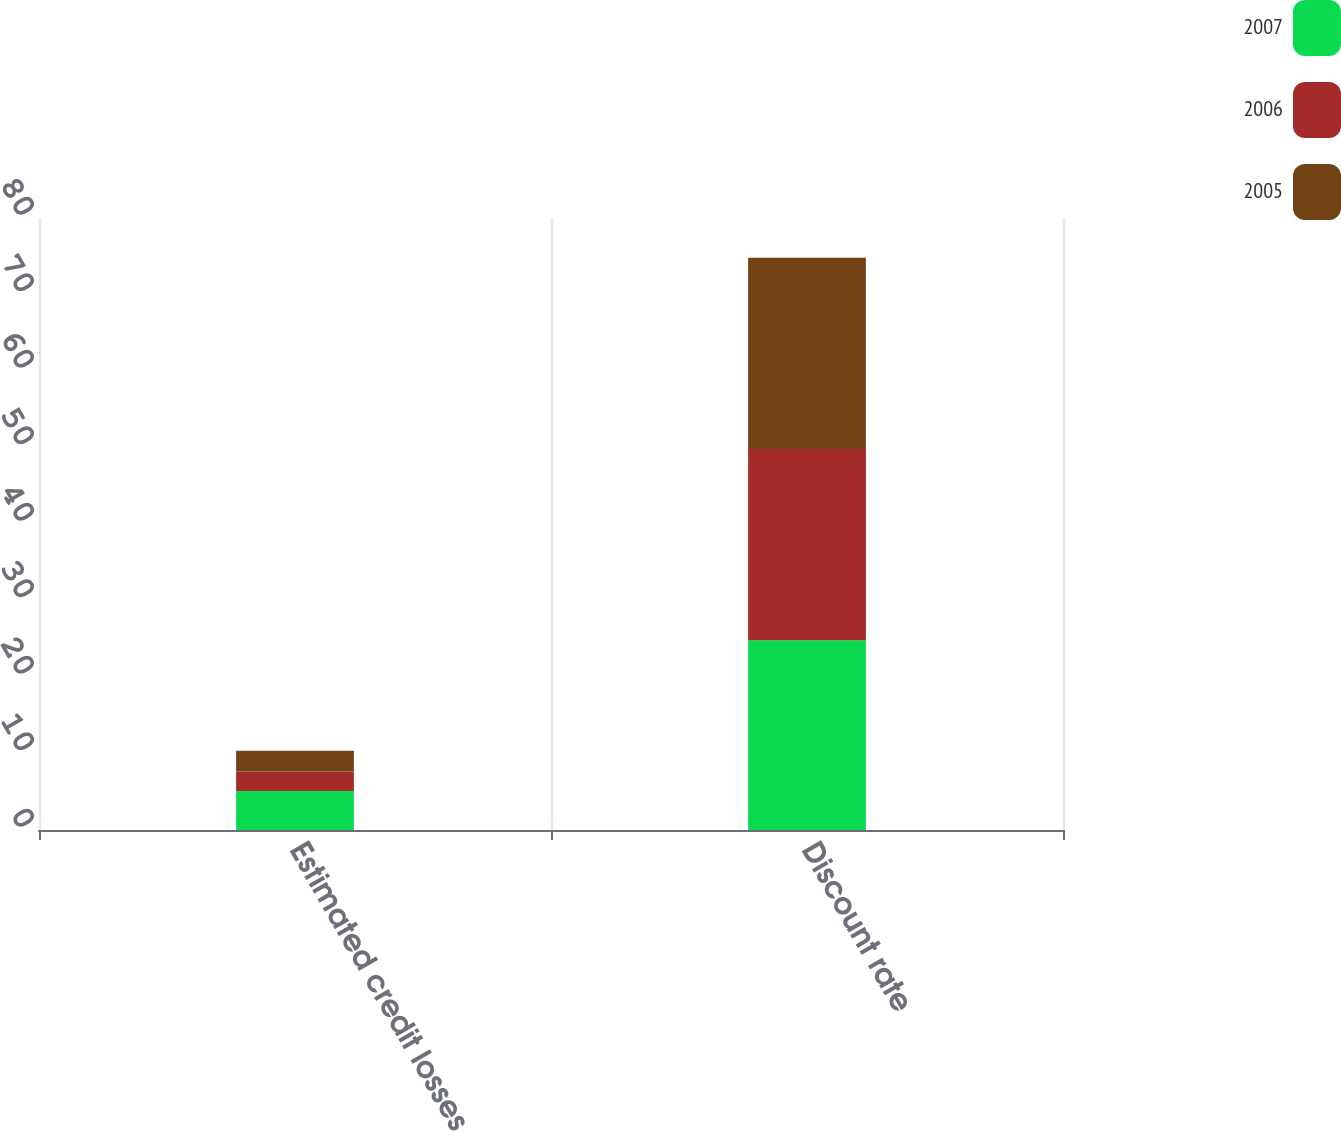<chart> <loc_0><loc_0><loc_500><loc_500><stacked_bar_chart><ecel><fcel>Estimated credit losses<fcel>Discount rate<nl><fcel>2007<fcel>5.09<fcel>24.79<nl><fcel>2006<fcel>2.55<fcel>25<nl><fcel>2005<fcel>2.72<fcel>25<nl></chart> 